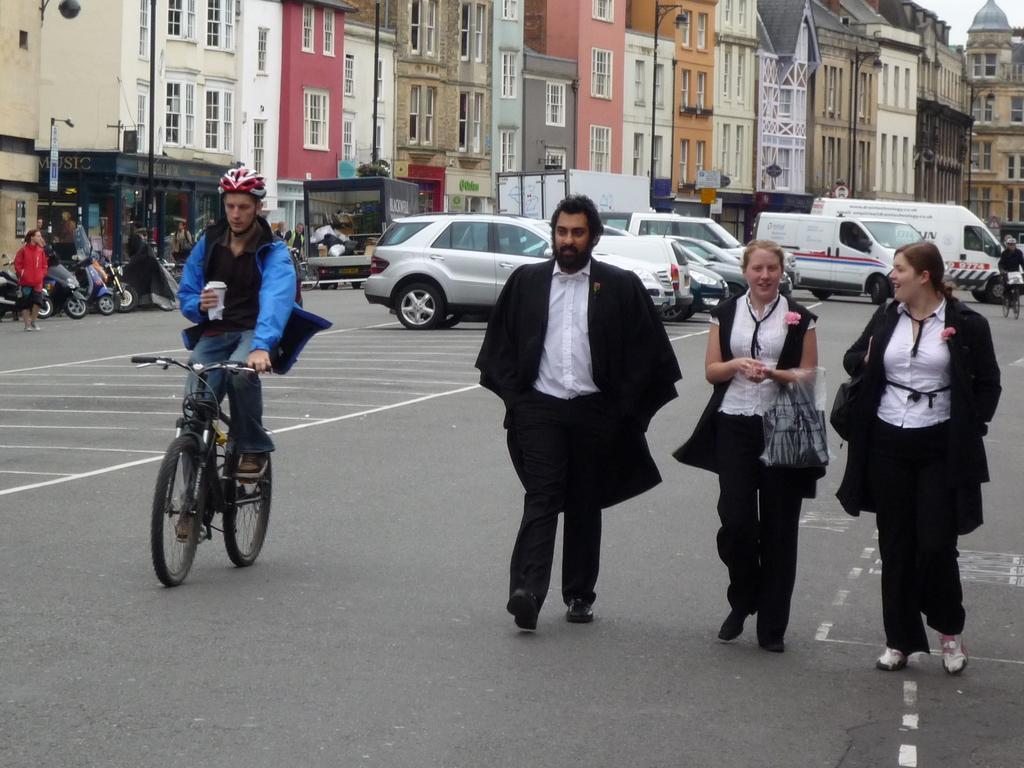Please provide a concise description of this image. On the background we can see buildings. We can see few vehicles parked near to the buildings. We can see vehicles running on the road. We can see a man wearing a helmet and he is holding a glass in his hand and riding bicycle. We can see three persons talking and walking on the road. 